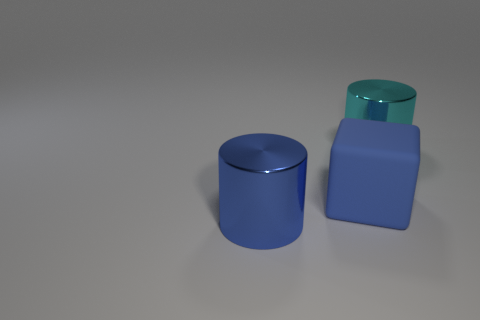Add 2 large cyan matte objects. How many objects exist? 5 Subtract all cylinders. How many objects are left? 1 Add 1 small green matte things. How many small green matte things exist? 1 Subtract 0 yellow cylinders. How many objects are left? 3 Subtract all tiny brown things. Subtract all big objects. How many objects are left? 0 Add 2 blue things. How many blue things are left? 4 